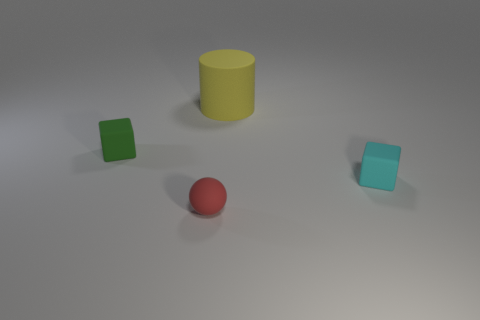What is the big cylinder made of?
Your response must be concise. Rubber. The rubber object that is behind the block behind the cube that is right of the green rubber object is what color?
Provide a short and direct response. Yellow. There is another small thing that is the same shape as the tiny cyan object; what is it made of?
Your response must be concise. Rubber. There is a rubber object behind the tiny matte block that is left of the large rubber cylinder; what size is it?
Provide a succinct answer. Large. There is a yellow cylinder that is made of the same material as the cyan object; what is its size?
Offer a very short reply. Large. What number of small cyan objects are the same shape as the red thing?
Your answer should be very brief. 0. Does the tiny green rubber thing have the same shape as the small thing that is right of the large rubber cylinder?
Your answer should be compact. Yes. Is there a red object that has the same material as the green block?
Give a very brief answer. Yes. What is the size of the yellow cylinder left of the tiny object that is on the right side of the rubber cylinder behind the matte ball?
Offer a terse response. Large. How many other objects are there of the same shape as the large yellow object?
Offer a terse response. 0. 